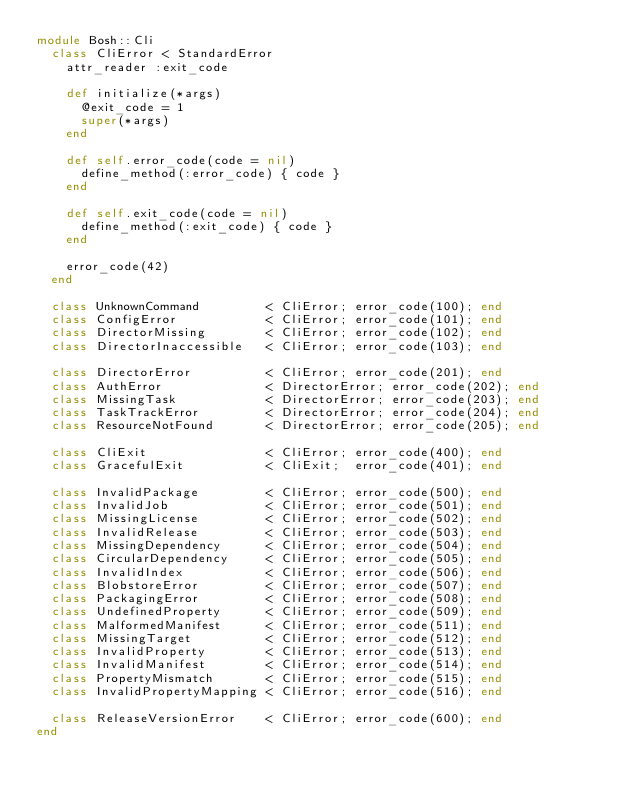<code> <loc_0><loc_0><loc_500><loc_500><_Ruby_>module Bosh::Cli
  class CliError < StandardError
    attr_reader :exit_code

    def initialize(*args)
      @exit_code = 1
      super(*args)
    end

    def self.error_code(code = nil)
      define_method(:error_code) { code }
    end

    def self.exit_code(code = nil)
      define_method(:exit_code) { code }
    end

    error_code(42)
  end

  class UnknownCommand         < CliError; error_code(100); end
  class ConfigError            < CliError; error_code(101); end
  class DirectorMissing        < CliError; error_code(102); end
  class DirectorInaccessible   < CliError; error_code(103); end

  class DirectorError          < CliError; error_code(201); end
  class AuthError              < DirectorError; error_code(202); end
  class MissingTask            < DirectorError; error_code(203); end
  class TaskTrackError         < DirectorError; error_code(204); end
  class ResourceNotFound       < DirectorError; error_code(205); end

  class CliExit                < CliError; error_code(400); end
  class GracefulExit           < CliExit;  error_code(401); end

  class InvalidPackage         < CliError; error_code(500); end
  class InvalidJob             < CliError; error_code(501); end
  class MissingLicense         < CliError; error_code(502); end
  class InvalidRelease         < CliError; error_code(503); end
  class MissingDependency      < CliError; error_code(504); end
  class CircularDependency     < CliError; error_code(505); end
  class InvalidIndex           < CliError; error_code(506); end
  class BlobstoreError         < CliError; error_code(507); end
  class PackagingError         < CliError; error_code(508); end
  class UndefinedProperty      < CliError; error_code(509); end
  class MalformedManifest      < CliError; error_code(511); end
  class MissingTarget          < CliError; error_code(512); end
  class InvalidProperty        < CliError; error_code(513); end
  class InvalidManifest        < CliError; error_code(514); end
  class PropertyMismatch       < CliError; error_code(515); end
  class InvalidPropertyMapping < CliError; error_code(516); end

  class ReleaseVersionError    < CliError; error_code(600); end
end
</code> 